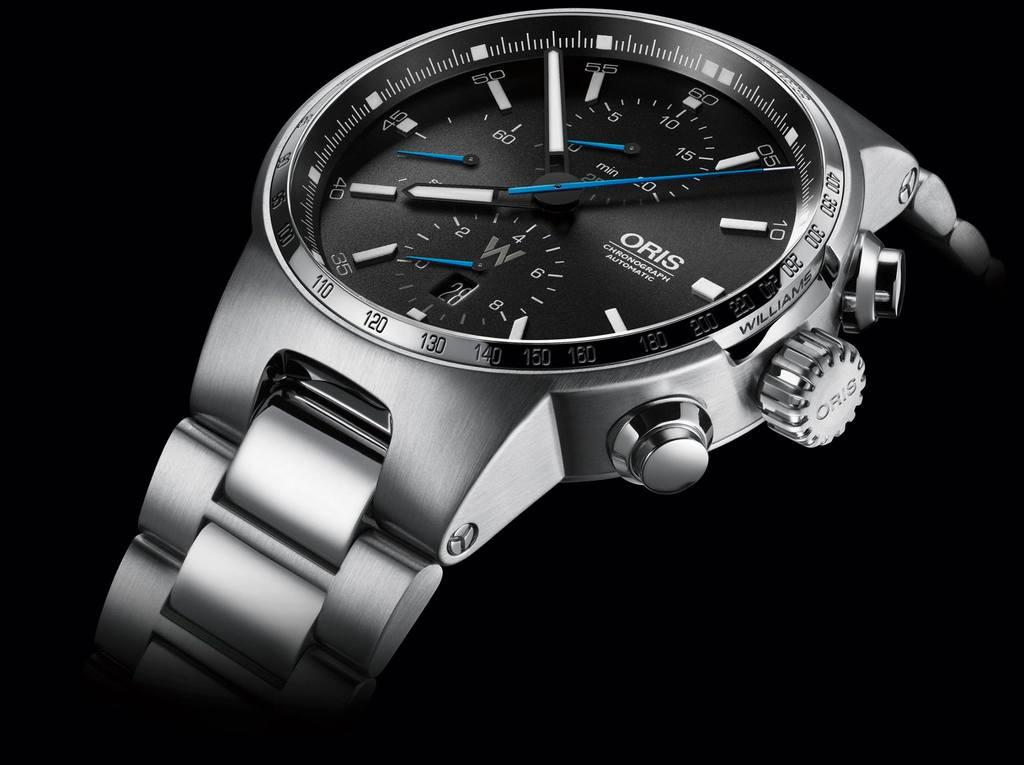<image>
Relay a brief, clear account of the picture shown. Silver wristwatch which has the word ORIS on it. 